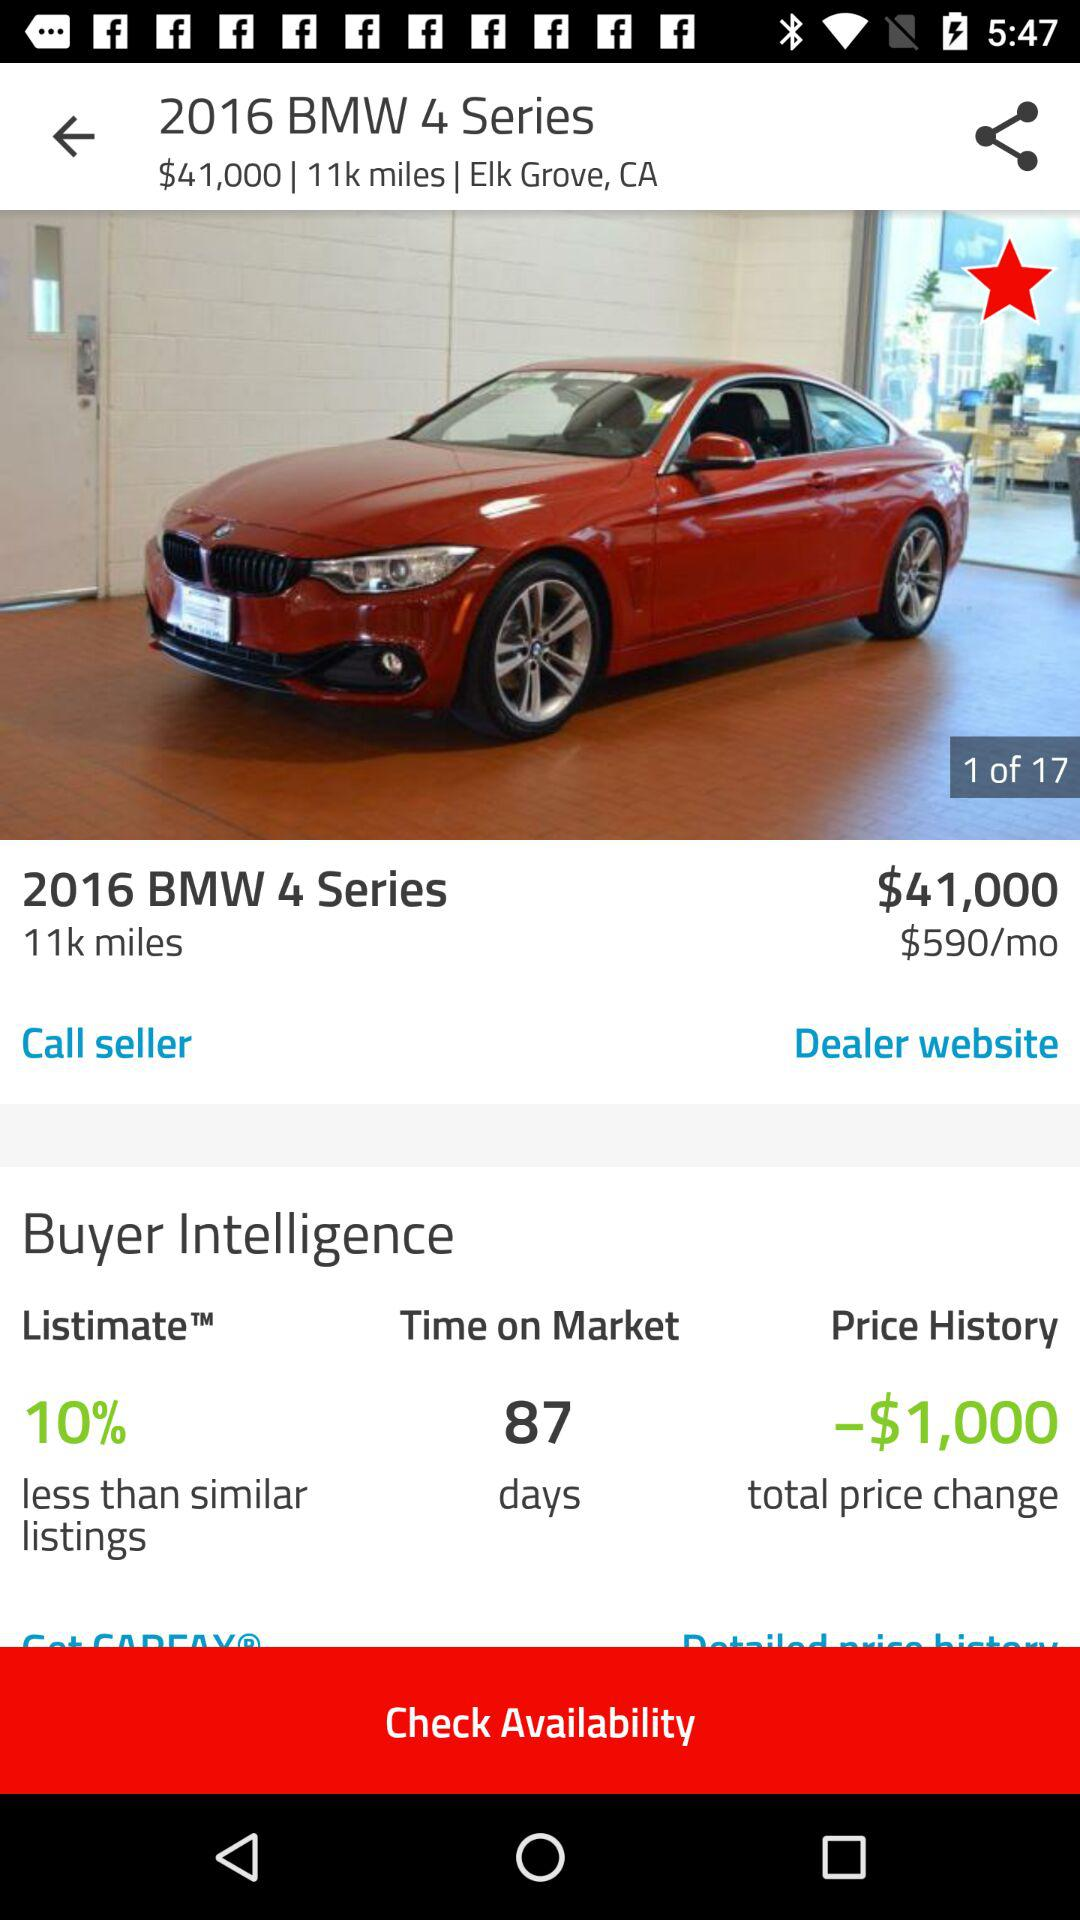What is the name of the car? The name of the car is "2016 BMW 4 Series". 